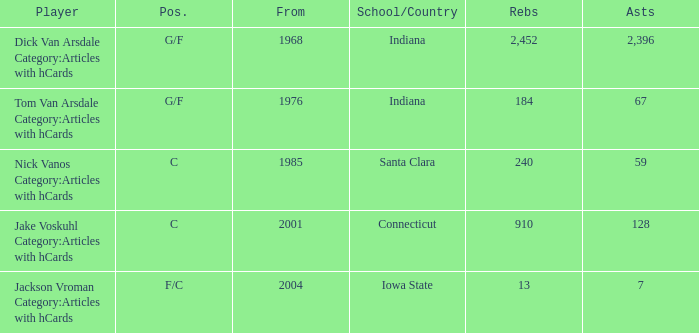What is the highest number of assists for players that are f/c and have under 13 rebounds? None. 